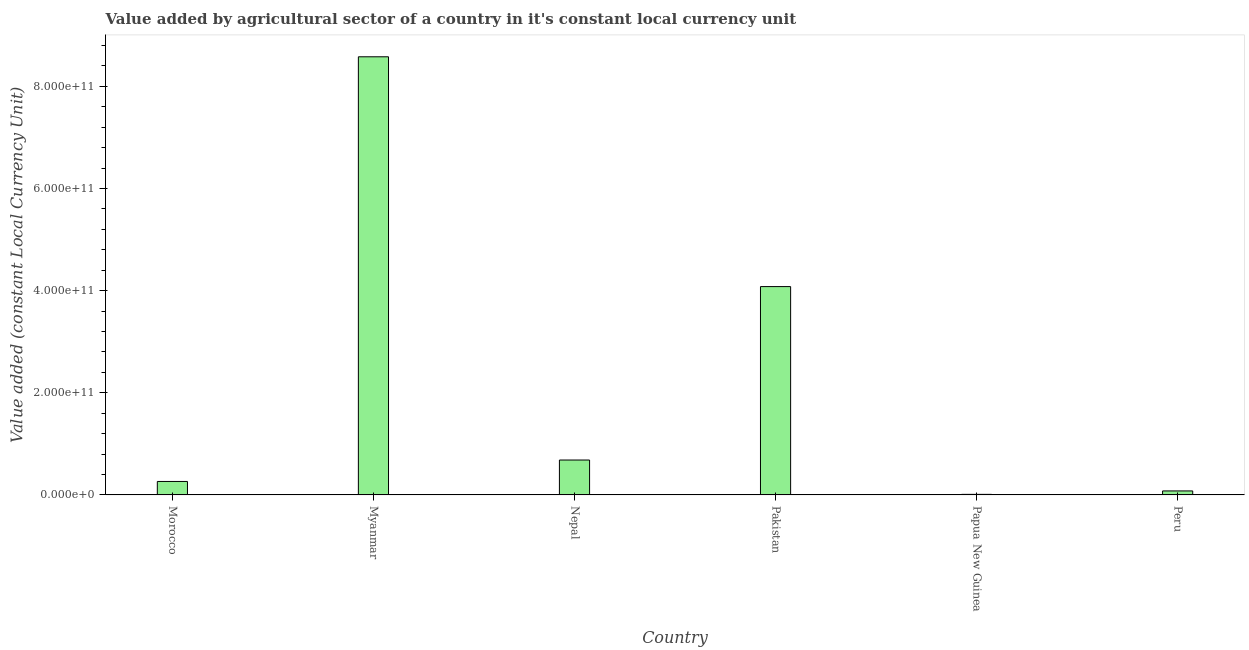Does the graph contain grids?
Give a very brief answer. No. What is the title of the graph?
Offer a very short reply. Value added by agricultural sector of a country in it's constant local currency unit. What is the label or title of the X-axis?
Your answer should be compact. Country. What is the label or title of the Y-axis?
Provide a short and direct response. Value added (constant Local Currency Unit). What is the value added by agriculture sector in Myanmar?
Make the answer very short. 8.58e+11. Across all countries, what is the maximum value added by agriculture sector?
Ensure brevity in your answer.  8.58e+11. Across all countries, what is the minimum value added by agriculture sector?
Your response must be concise. 1.10e+09. In which country was the value added by agriculture sector maximum?
Provide a short and direct response. Myanmar. In which country was the value added by agriculture sector minimum?
Your response must be concise. Papua New Guinea. What is the sum of the value added by agriculture sector?
Your response must be concise. 1.37e+12. What is the difference between the value added by agriculture sector in Morocco and Myanmar?
Your answer should be very brief. -8.32e+11. What is the average value added by agriculture sector per country?
Offer a very short reply. 2.28e+11. What is the median value added by agriculture sector?
Give a very brief answer. 4.74e+1. What is the ratio of the value added by agriculture sector in Pakistan to that in Papua New Guinea?
Keep it short and to the point. 370.48. Is the value added by agriculture sector in Nepal less than that in Papua New Guinea?
Offer a very short reply. No. Is the difference between the value added by agriculture sector in Myanmar and Nepal greater than the difference between any two countries?
Offer a very short reply. No. What is the difference between the highest and the second highest value added by agriculture sector?
Offer a terse response. 4.50e+11. What is the difference between the highest and the lowest value added by agriculture sector?
Give a very brief answer. 8.57e+11. In how many countries, is the value added by agriculture sector greater than the average value added by agriculture sector taken over all countries?
Your response must be concise. 2. How many bars are there?
Offer a terse response. 6. How many countries are there in the graph?
Provide a short and direct response. 6. What is the difference between two consecutive major ticks on the Y-axis?
Give a very brief answer. 2.00e+11. What is the Value added (constant Local Currency Unit) of Morocco?
Keep it short and to the point. 2.64e+1. What is the Value added (constant Local Currency Unit) of Myanmar?
Keep it short and to the point. 8.58e+11. What is the Value added (constant Local Currency Unit) of Nepal?
Give a very brief answer. 6.84e+1. What is the Value added (constant Local Currency Unit) of Pakistan?
Offer a very short reply. 4.08e+11. What is the Value added (constant Local Currency Unit) of Papua New Guinea?
Ensure brevity in your answer.  1.10e+09. What is the Value added (constant Local Currency Unit) in Peru?
Your response must be concise. 7.84e+09. What is the difference between the Value added (constant Local Currency Unit) in Morocco and Myanmar?
Give a very brief answer. -8.32e+11. What is the difference between the Value added (constant Local Currency Unit) in Morocco and Nepal?
Your response must be concise. -4.20e+1. What is the difference between the Value added (constant Local Currency Unit) in Morocco and Pakistan?
Give a very brief answer. -3.82e+11. What is the difference between the Value added (constant Local Currency Unit) in Morocco and Papua New Guinea?
Your answer should be very brief. 2.53e+1. What is the difference between the Value added (constant Local Currency Unit) in Morocco and Peru?
Ensure brevity in your answer.  1.85e+1. What is the difference between the Value added (constant Local Currency Unit) in Myanmar and Nepal?
Your response must be concise. 7.90e+11. What is the difference between the Value added (constant Local Currency Unit) in Myanmar and Pakistan?
Keep it short and to the point. 4.50e+11. What is the difference between the Value added (constant Local Currency Unit) in Myanmar and Papua New Guinea?
Keep it short and to the point. 8.57e+11. What is the difference between the Value added (constant Local Currency Unit) in Myanmar and Peru?
Offer a very short reply. 8.50e+11. What is the difference between the Value added (constant Local Currency Unit) in Nepal and Pakistan?
Your answer should be very brief. -3.40e+11. What is the difference between the Value added (constant Local Currency Unit) in Nepal and Papua New Guinea?
Provide a short and direct response. 6.73e+1. What is the difference between the Value added (constant Local Currency Unit) in Nepal and Peru?
Ensure brevity in your answer.  6.05e+1. What is the difference between the Value added (constant Local Currency Unit) in Pakistan and Papua New Guinea?
Your answer should be very brief. 4.07e+11. What is the difference between the Value added (constant Local Currency Unit) in Pakistan and Peru?
Give a very brief answer. 4.00e+11. What is the difference between the Value added (constant Local Currency Unit) in Papua New Guinea and Peru?
Give a very brief answer. -6.74e+09. What is the ratio of the Value added (constant Local Currency Unit) in Morocco to that in Myanmar?
Offer a terse response. 0.03. What is the ratio of the Value added (constant Local Currency Unit) in Morocco to that in Nepal?
Ensure brevity in your answer.  0.39. What is the ratio of the Value added (constant Local Currency Unit) in Morocco to that in Pakistan?
Provide a succinct answer. 0.07. What is the ratio of the Value added (constant Local Currency Unit) in Morocco to that in Papua New Guinea?
Provide a short and direct response. 23.97. What is the ratio of the Value added (constant Local Currency Unit) in Morocco to that in Peru?
Provide a short and direct response. 3.36. What is the ratio of the Value added (constant Local Currency Unit) in Myanmar to that in Nepal?
Give a very brief answer. 12.55. What is the ratio of the Value added (constant Local Currency Unit) in Myanmar to that in Pakistan?
Keep it short and to the point. 2.1. What is the ratio of the Value added (constant Local Currency Unit) in Myanmar to that in Papua New Guinea?
Ensure brevity in your answer.  779.14. What is the ratio of the Value added (constant Local Currency Unit) in Myanmar to that in Peru?
Your answer should be very brief. 109.37. What is the ratio of the Value added (constant Local Currency Unit) in Nepal to that in Pakistan?
Provide a succinct answer. 0.17. What is the ratio of the Value added (constant Local Currency Unit) in Nepal to that in Papua New Guinea?
Provide a short and direct response. 62.08. What is the ratio of the Value added (constant Local Currency Unit) in Nepal to that in Peru?
Give a very brief answer. 8.71. What is the ratio of the Value added (constant Local Currency Unit) in Pakistan to that in Papua New Guinea?
Your response must be concise. 370.48. What is the ratio of the Value added (constant Local Currency Unit) in Pakistan to that in Peru?
Your response must be concise. 52.01. What is the ratio of the Value added (constant Local Currency Unit) in Papua New Guinea to that in Peru?
Your response must be concise. 0.14. 